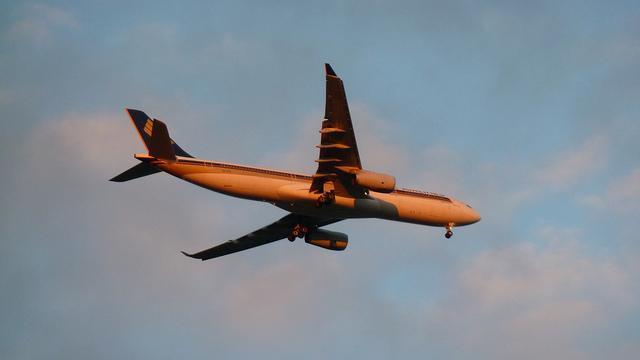How many elephants are there?
Give a very brief answer. 0. 